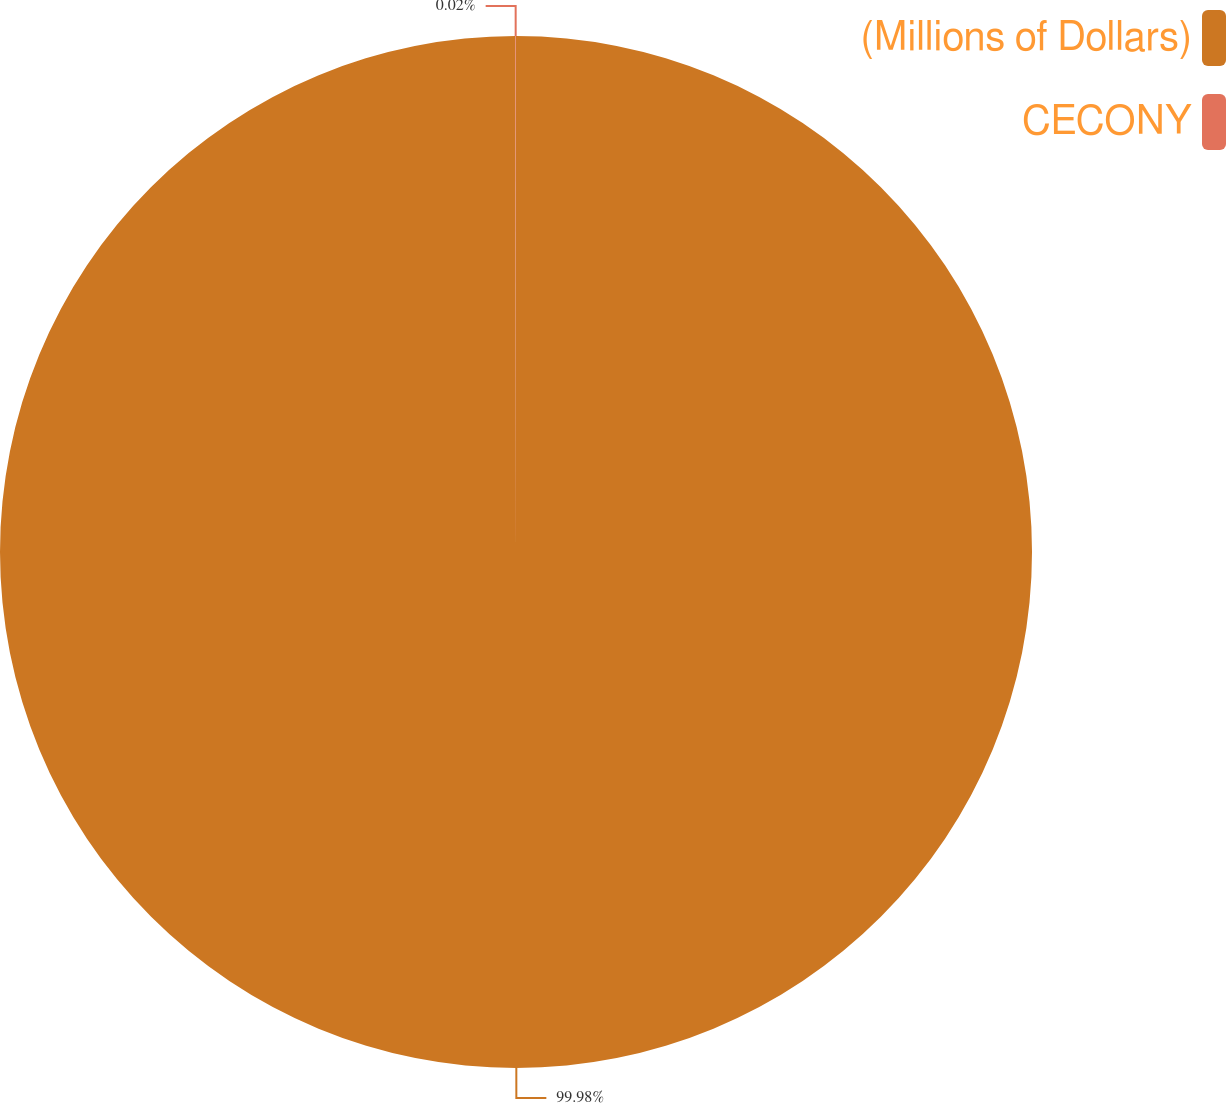Convert chart to OTSL. <chart><loc_0><loc_0><loc_500><loc_500><pie_chart><fcel>(Millions of Dollars)<fcel>CECONY<nl><fcel>99.98%<fcel>0.02%<nl></chart> 